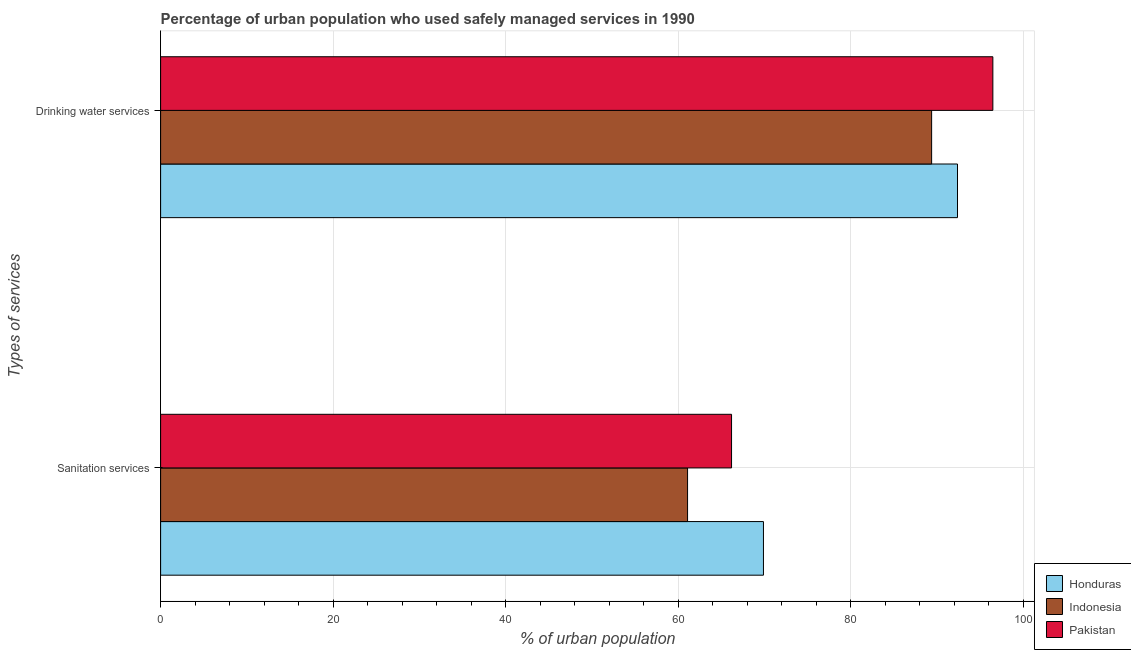Are the number of bars on each tick of the Y-axis equal?
Provide a short and direct response. Yes. How many bars are there on the 2nd tick from the top?
Your answer should be compact. 3. How many bars are there on the 2nd tick from the bottom?
Offer a very short reply. 3. What is the label of the 1st group of bars from the top?
Offer a terse response. Drinking water services. What is the percentage of urban population who used drinking water services in Honduras?
Offer a terse response. 92.4. Across all countries, what is the maximum percentage of urban population who used drinking water services?
Provide a short and direct response. 96.5. Across all countries, what is the minimum percentage of urban population who used drinking water services?
Provide a succinct answer. 89.4. In which country was the percentage of urban population who used drinking water services maximum?
Your response must be concise. Pakistan. In which country was the percentage of urban population who used sanitation services minimum?
Offer a very short reply. Indonesia. What is the total percentage of urban population who used sanitation services in the graph?
Provide a succinct answer. 197.2. What is the difference between the percentage of urban population who used drinking water services in Honduras and that in Pakistan?
Make the answer very short. -4.1. What is the difference between the percentage of urban population who used sanitation services in Pakistan and the percentage of urban population who used drinking water services in Indonesia?
Give a very brief answer. -23.2. What is the average percentage of urban population who used drinking water services per country?
Make the answer very short. 92.77. What is the difference between the percentage of urban population who used sanitation services and percentage of urban population who used drinking water services in Honduras?
Your answer should be compact. -22.5. What is the ratio of the percentage of urban population who used sanitation services in Honduras to that in Pakistan?
Provide a succinct answer. 1.06. Is the percentage of urban population who used sanitation services in Indonesia less than that in Pakistan?
Provide a succinct answer. Yes. In how many countries, is the percentage of urban population who used sanitation services greater than the average percentage of urban population who used sanitation services taken over all countries?
Offer a terse response. 2. How many bars are there?
Your answer should be compact. 6. Are the values on the major ticks of X-axis written in scientific E-notation?
Offer a very short reply. No. What is the title of the graph?
Provide a short and direct response. Percentage of urban population who used safely managed services in 1990. What is the label or title of the X-axis?
Offer a terse response. % of urban population. What is the label or title of the Y-axis?
Give a very brief answer. Types of services. What is the % of urban population in Honduras in Sanitation services?
Make the answer very short. 69.9. What is the % of urban population of Indonesia in Sanitation services?
Ensure brevity in your answer.  61.1. What is the % of urban population of Pakistan in Sanitation services?
Give a very brief answer. 66.2. What is the % of urban population in Honduras in Drinking water services?
Make the answer very short. 92.4. What is the % of urban population in Indonesia in Drinking water services?
Ensure brevity in your answer.  89.4. What is the % of urban population of Pakistan in Drinking water services?
Ensure brevity in your answer.  96.5. Across all Types of services, what is the maximum % of urban population in Honduras?
Your answer should be very brief. 92.4. Across all Types of services, what is the maximum % of urban population in Indonesia?
Offer a terse response. 89.4. Across all Types of services, what is the maximum % of urban population in Pakistan?
Ensure brevity in your answer.  96.5. Across all Types of services, what is the minimum % of urban population of Honduras?
Ensure brevity in your answer.  69.9. Across all Types of services, what is the minimum % of urban population of Indonesia?
Your answer should be very brief. 61.1. Across all Types of services, what is the minimum % of urban population in Pakistan?
Make the answer very short. 66.2. What is the total % of urban population of Honduras in the graph?
Give a very brief answer. 162.3. What is the total % of urban population of Indonesia in the graph?
Your response must be concise. 150.5. What is the total % of urban population in Pakistan in the graph?
Offer a very short reply. 162.7. What is the difference between the % of urban population of Honduras in Sanitation services and that in Drinking water services?
Your response must be concise. -22.5. What is the difference between the % of urban population in Indonesia in Sanitation services and that in Drinking water services?
Ensure brevity in your answer.  -28.3. What is the difference between the % of urban population of Pakistan in Sanitation services and that in Drinking water services?
Provide a short and direct response. -30.3. What is the difference between the % of urban population of Honduras in Sanitation services and the % of urban population of Indonesia in Drinking water services?
Keep it short and to the point. -19.5. What is the difference between the % of urban population in Honduras in Sanitation services and the % of urban population in Pakistan in Drinking water services?
Your answer should be compact. -26.6. What is the difference between the % of urban population in Indonesia in Sanitation services and the % of urban population in Pakistan in Drinking water services?
Your answer should be compact. -35.4. What is the average % of urban population in Honduras per Types of services?
Your response must be concise. 81.15. What is the average % of urban population of Indonesia per Types of services?
Give a very brief answer. 75.25. What is the average % of urban population in Pakistan per Types of services?
Offer a very short reply. 81.35. What is the difference between the % of urban population of Honduras and % of urban population of Indonesia in Sanitation services?
Offer a terse response. 8.8. What is the difference between the % of urban population of Honduras and % of urban population of Indonesia in Drinking water services?
Provide a short and direct response. 3. What is the difference between the % of urban population in Honduras and % of urban population in Pakistan in Drinking water services?
Make the answer very short. -4.1. What is the ratio of the % of urban population in Honduras in Sanitation services to that in Drinking water services?
Offer a terse response. 0.76. What is the ratio of the % of urban population in Indonesia in Sanitation services to that in Drinking water services?
Provide a short and direct response. 0.68. What is the ratio of the % of urban population in Pakistan in Sanitation services to that in Drinking water services?
Offer a very short reply. 0.69. What is the difference between the highest and the second highest % of urban population in Indonesia?
Your response must be concise. 28.3. What is the difference between the highest and the second highest % of urban population of Pakistan?
Provide a succinct answer. 30.3. What is the difference between the highest and the lowest % of urban population in Honduras?
Provide a succinct answer. 22.5. What is the difference between the highest and the lowest % of urban population of Indonesia?
Give a very brief answer. 28.3. What is the difference between the highest and the lowest % of urban population in Pakistan?
Offer a terse response. 30.3. 